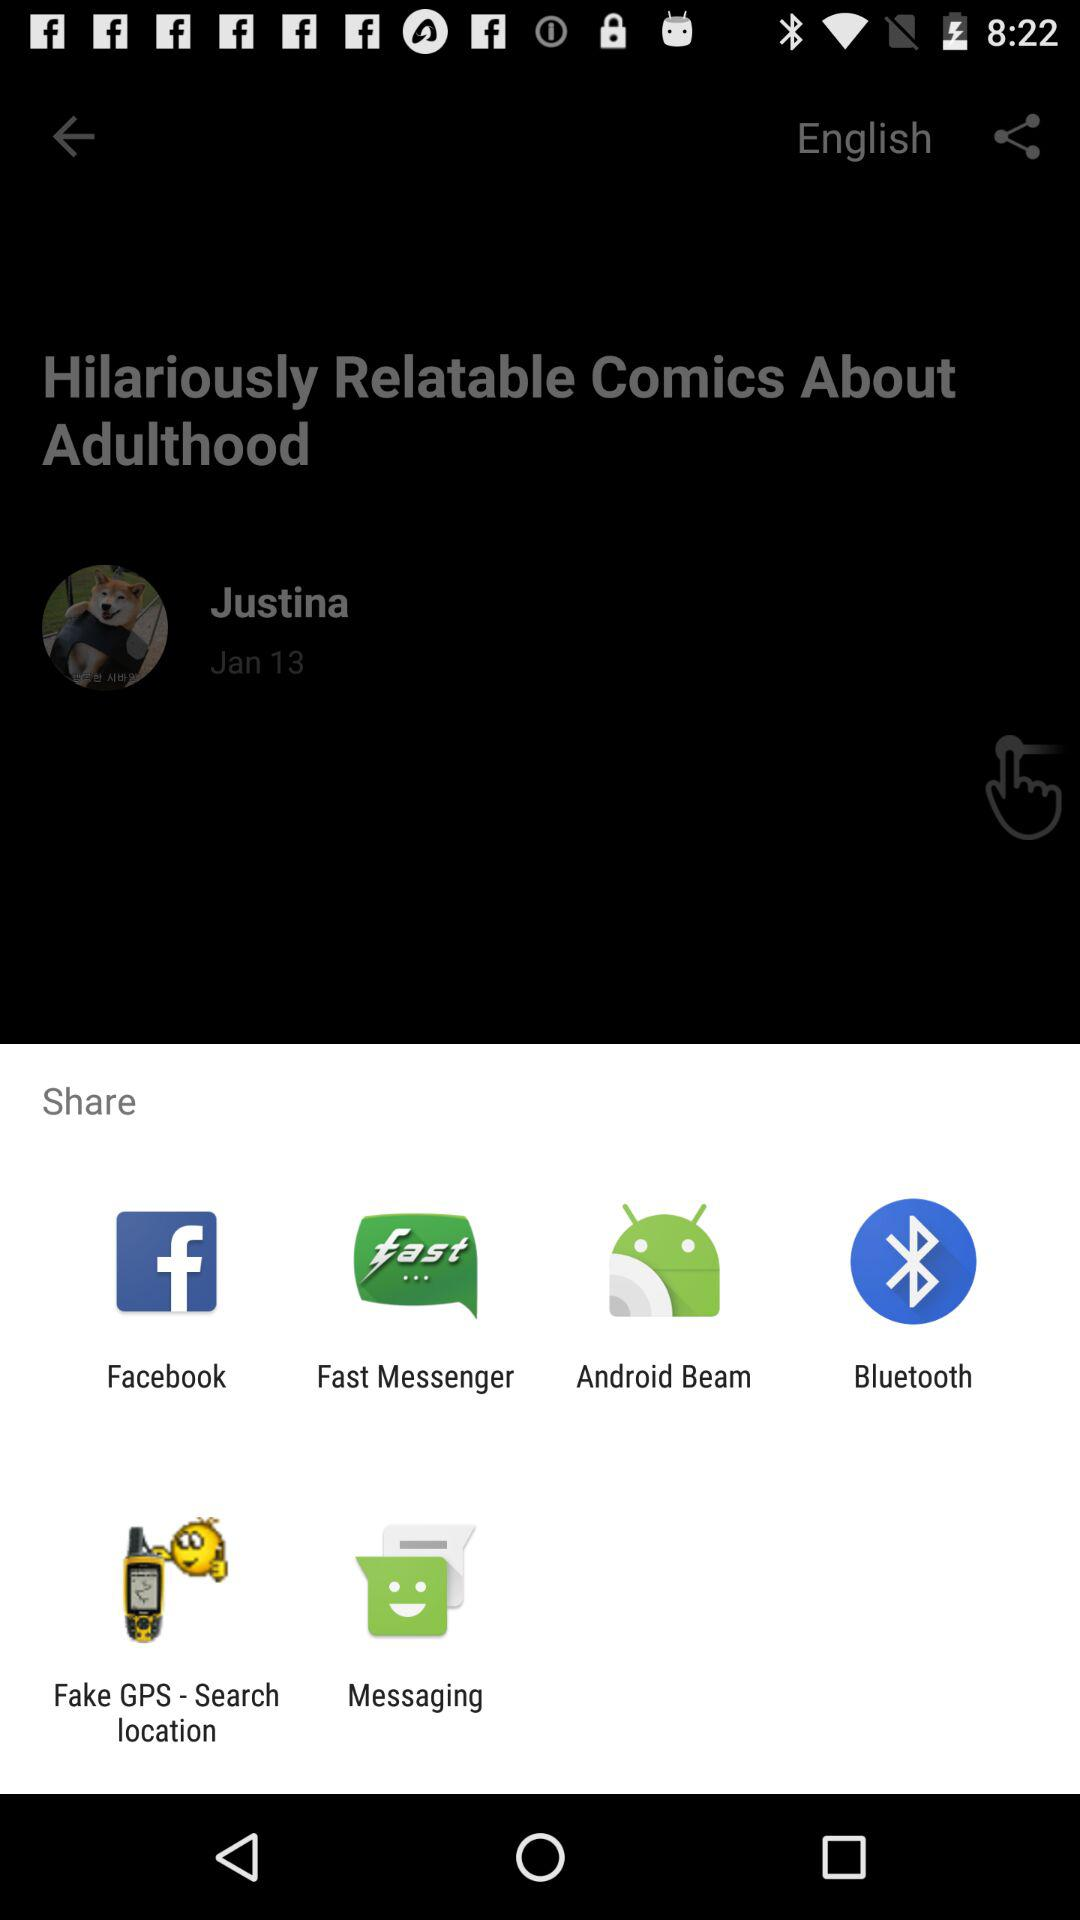What app can be used to share? You can share it with Facebook, Fast Messenger,Android Beam, Bluetooth, Fake GPS - Search location and Messaging. 